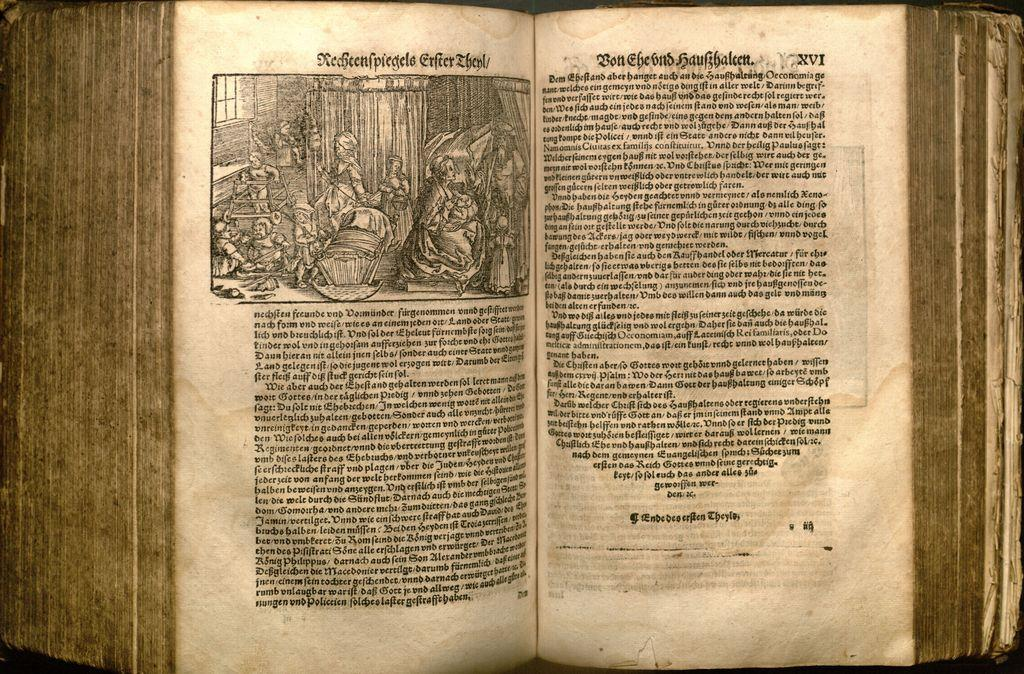<image>
Render a clear and concise summary of the photo. An ancient looking book open to page number XVI shows a black and white illustration. 